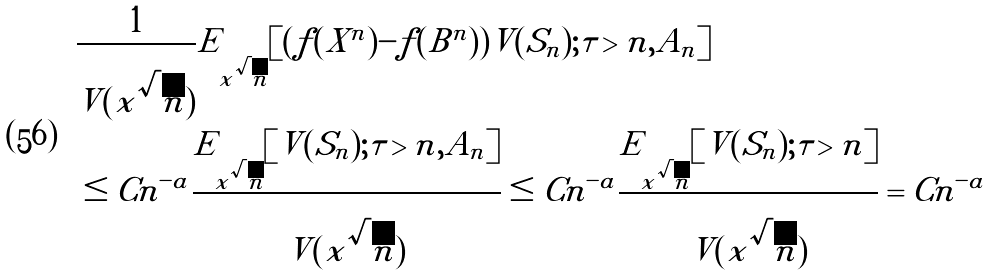<formula> <loc_0><loc_0><loc_500><loc_500>& \frac { 1 } { V ( x \sqrt { n } ) } E _ { x \sqrt { n } } [ ( f ( X ^ { n } ) - f ( B ^ { n } ) ) V ( S _ { n } ) ; \tau > n , A _ { n } ] \\ & \leq C n ^ { - a } \frac { E _ { x \sqrt { n } } [ V ( S _ { n } ) ; \tau > n , A _ { n } ] } { V ( x \sqrt { n } ) } \leq C n ^ { - a } \frac { E _ { x \sqrt { n } } [ V ( S _ { n } ) ; \tau > n ] } { V ( x \sqrt { n } ) } = C n ^ { - a }</formula> 